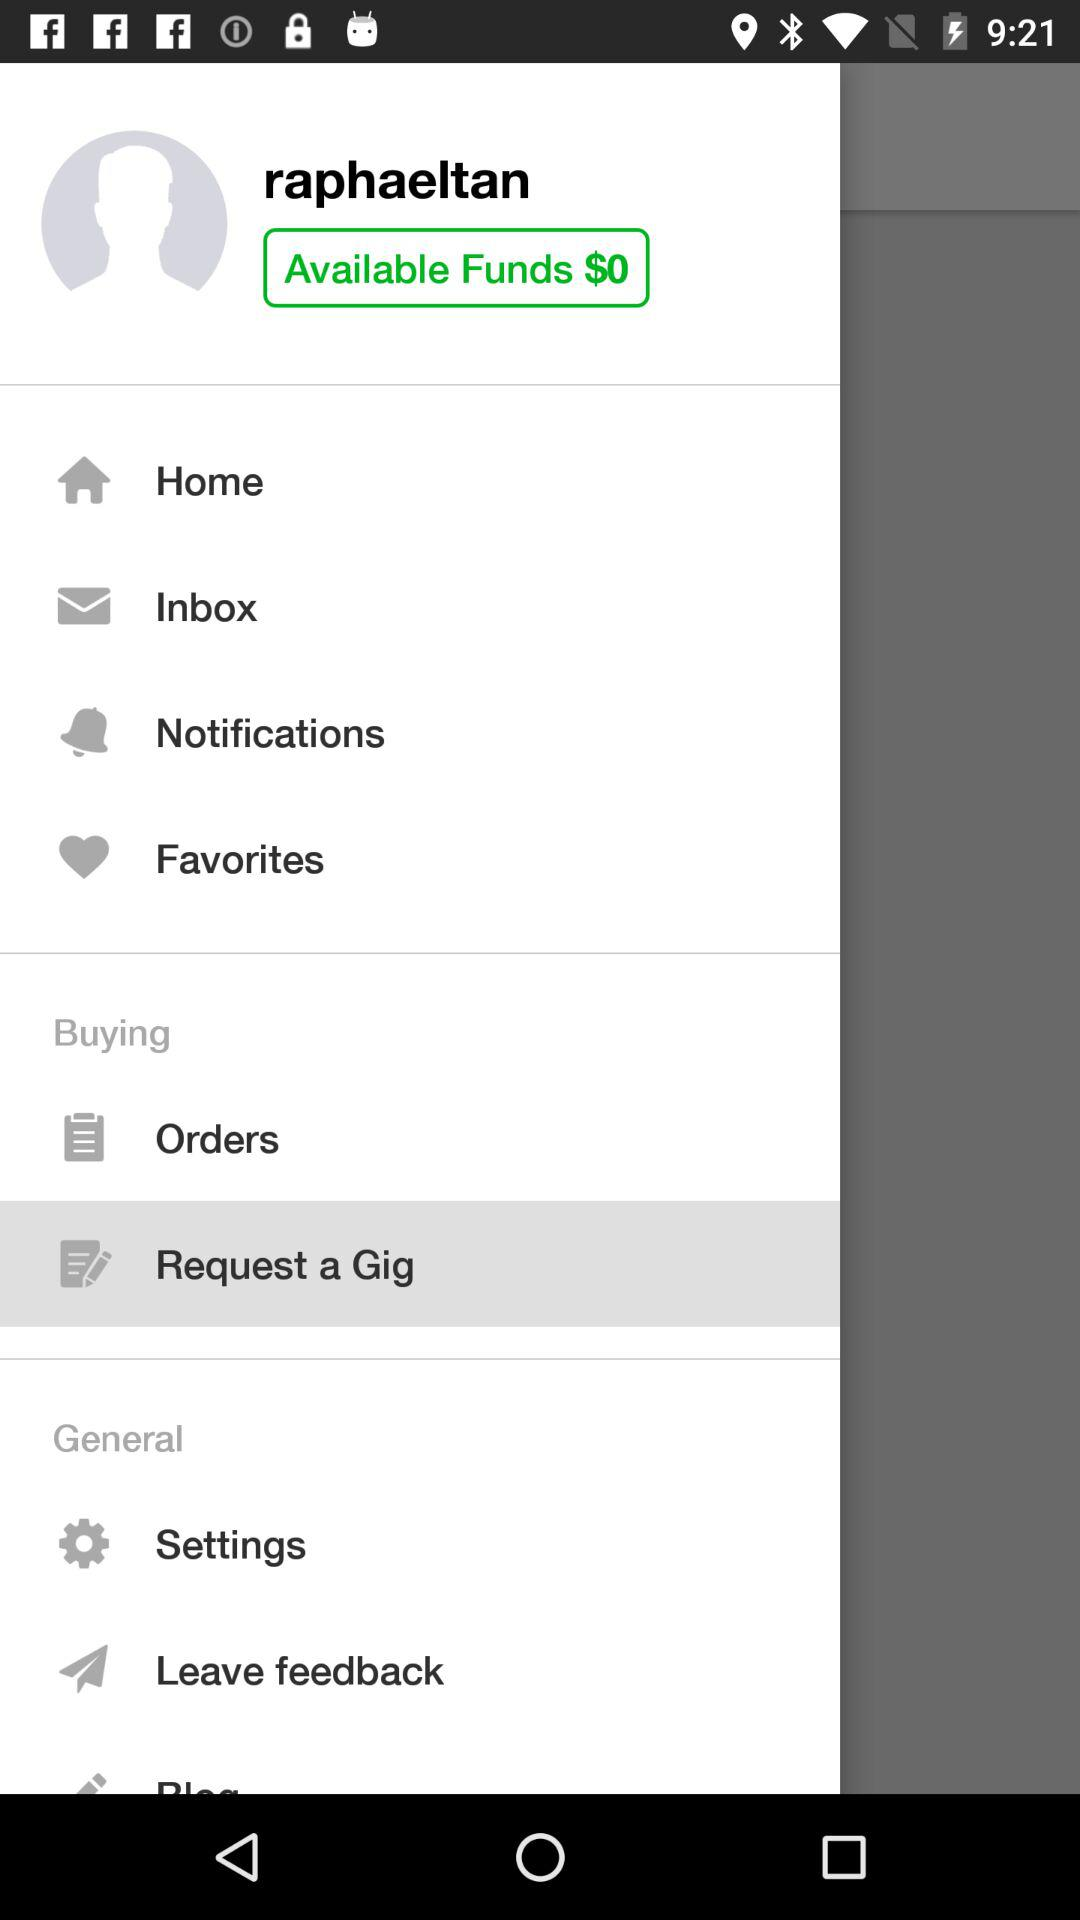How much do I have in my available funds?
Answer the question using a single word or phrase. $0 